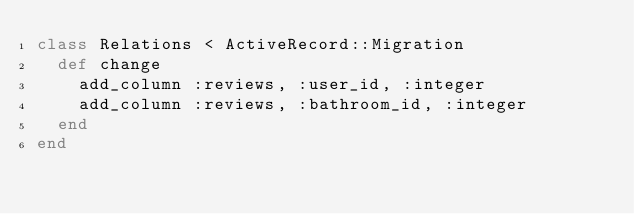Convert code to text. <code><loc_0><loc_0><loc_500><loc_500><_Ruby_>class Relations < ActiveRecord::Migration
  def change
    add_column :reviews, :user_id, :integer
    add_column :reviews, :bathroom_id, :integer
  end
end
</code> 